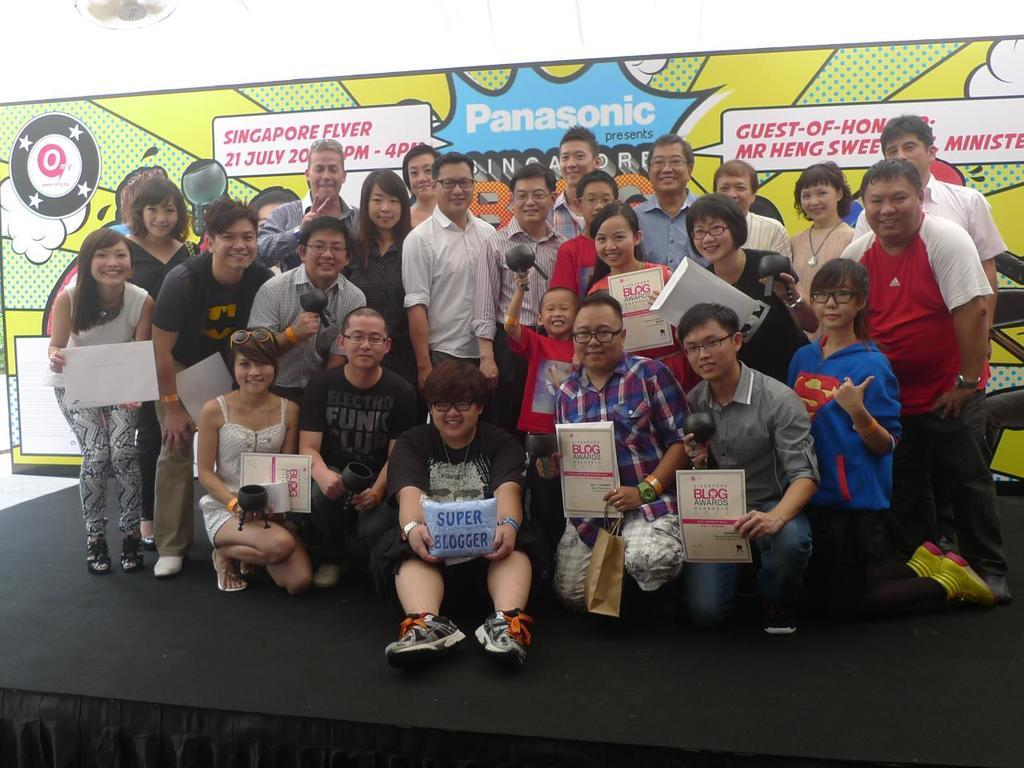What is happening on the stage in the image? There is a group of people on the stage in the image. What can be seen in the background of the image? There is a poster in the background of the image. What type of texture can be seen on the deer in the image? There is no deer present in the image. How many dimes are visible on the stage in the image? There are no dimes visible on the stage in the image. 